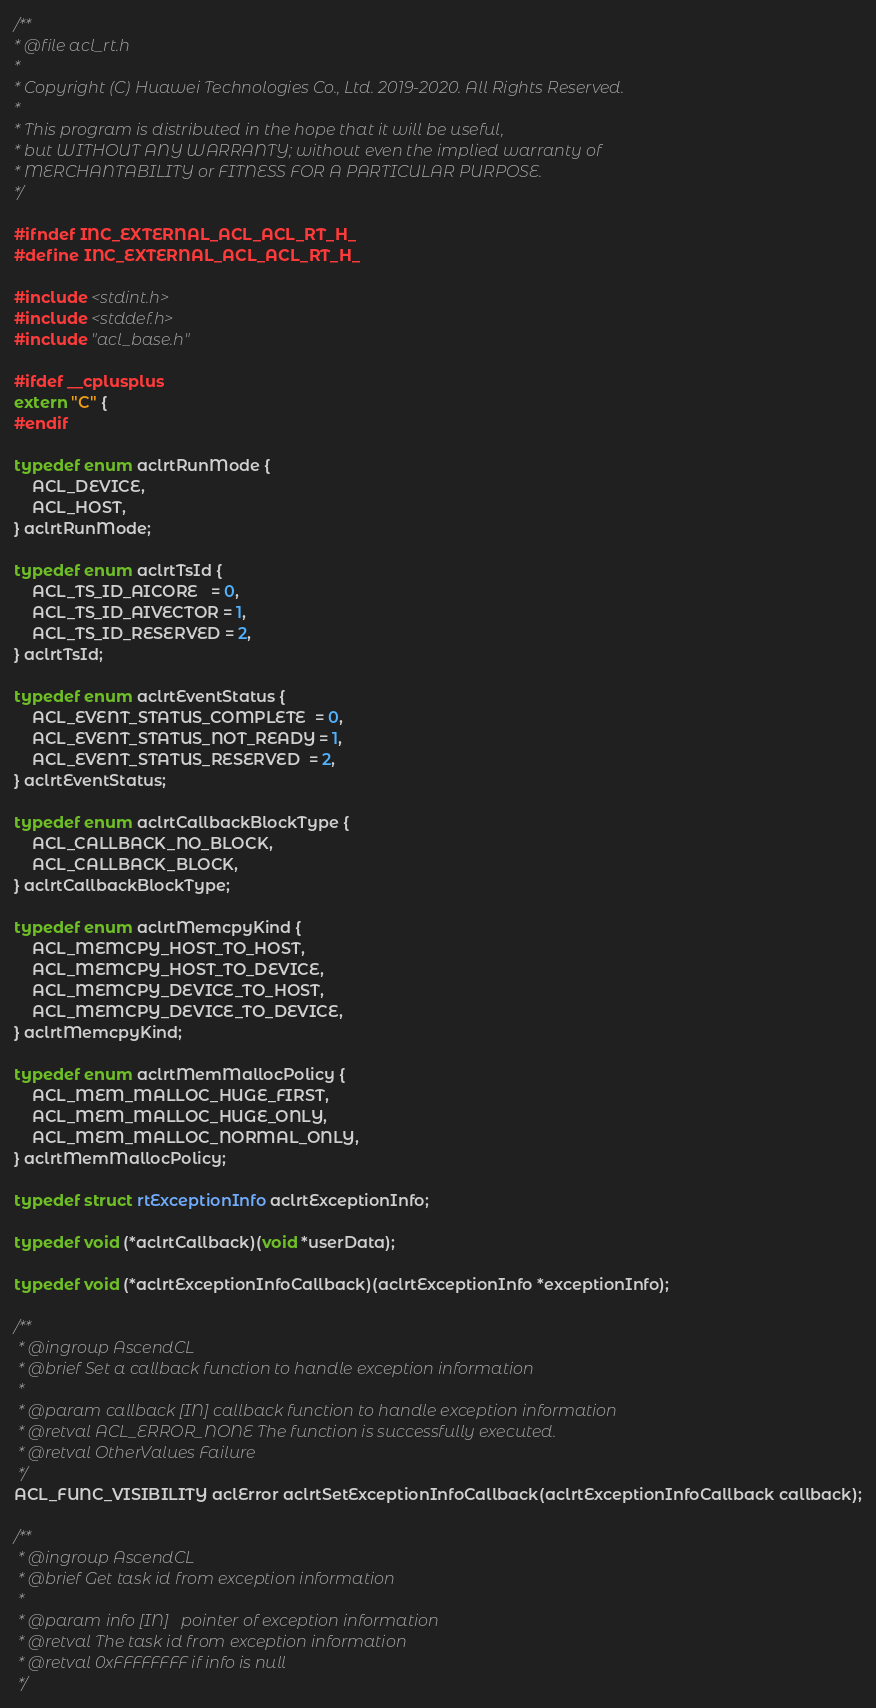Convert code to text. <code><loc_0><loc_0><loc_500><loc_500><_C_>/**
* @file acl_rt.h
*
* Copyright (C) Huawei Technologies Co., Ltd. 2019-2020. All Rights Reserved.
*
* This program is distributed in the hope that it will be useful,
* but WITHOUT ANY WARRANTY; without even the implied warranty of
* MERCHANTABILITY or FITNESS FOR A PARTICULAR PURPOSE.
*/

#ifndef INC_EXTERNAL_ACL_ACL_RT_H_
#define INC_EXTERNAL_ACL_ACL_RT_H_

#include <stdint.h>
#include <stddef.h>
#include "acl_base.h"

#ifdef __cplusplus
extern "C" {
#endif

typedef enum aclrtRunMode {
    ACL_DEVICE,
    ACL_HOST,
} aclrtRunMode;

typedef enum aclrtTsId {
    ACL_TS_ID_AICORE   = 0,
    ACL_TS_ID_AIVECTOR = 1,
    ACL_TS_ID_RESERVED = 2,
} aclrtTsId;

typedef enum aclrtEventStatus {
    ACL_EVENT_STATUS_COMPLETE  = 0,
    ACL_EVENT_STATUS_NOT_READY = 1,
    ACL_EVENT_STATUS_RESERVED  = 2,
} aclrtEventStatus;

typedef enum aclrtCallbackBlockType {
    ACL_CALLBACK_NO_BLOCK,
    ACL_CALLBACK_BLOCK,
} aclrtCallbackBlockType;

typedef enum aclrtMemcpyKind {
    ACL_MEMCPY_HOST_TO_HOST,
    ACL_MEMCPY_HOST_TO_DEVICE,
    ACL_MEMCPY_DEVICE_TO_HOST,
    ACL_MEMCPY_DEVICE_TO_DEVICE,
} aclrtMemcpyKind;

typedef enum aclrtMemMallocPolicy {
    ACL_MEM_MALLOC_HUGE_FIRST,
    ACL_MEM_MALLOC_HUGE_ONLY,
    ACL_MEM_MALLOC_NORMAL_ONLY,
} aclrtMemMallocPolicy;

typedef struct rtExceptionInfo aclrtExceptionInfo;

typedef void (*aclrtCallback)(void *userData);

typedef void (*aclrtExceptionInfoCallback)(aclrtExceptionInfo *exceptionInfo);

/**
 * @ingroup AscendCL
 * @brief Set a callback function to handle exception information
 *
 * @param callback [IN] callback function to handle exception information
 * @retval ACL_ERROR_NONE The function is successfully executed.
 * @retval OtherValues Failure
 */
ACL_FUNC_VISIBILITY aclError aclrtSetExceptionInfoCallback(aclrtExceptionInfoCallback callback);

/**
 * @ingroup AscendCL
 * @brief Get task id from exception information
 *
 * @param info [IN]   pointer of exception information
 * @retval The task id from exception information
 * @retval 0xFFFFFFFF if info is null
 */</code> 